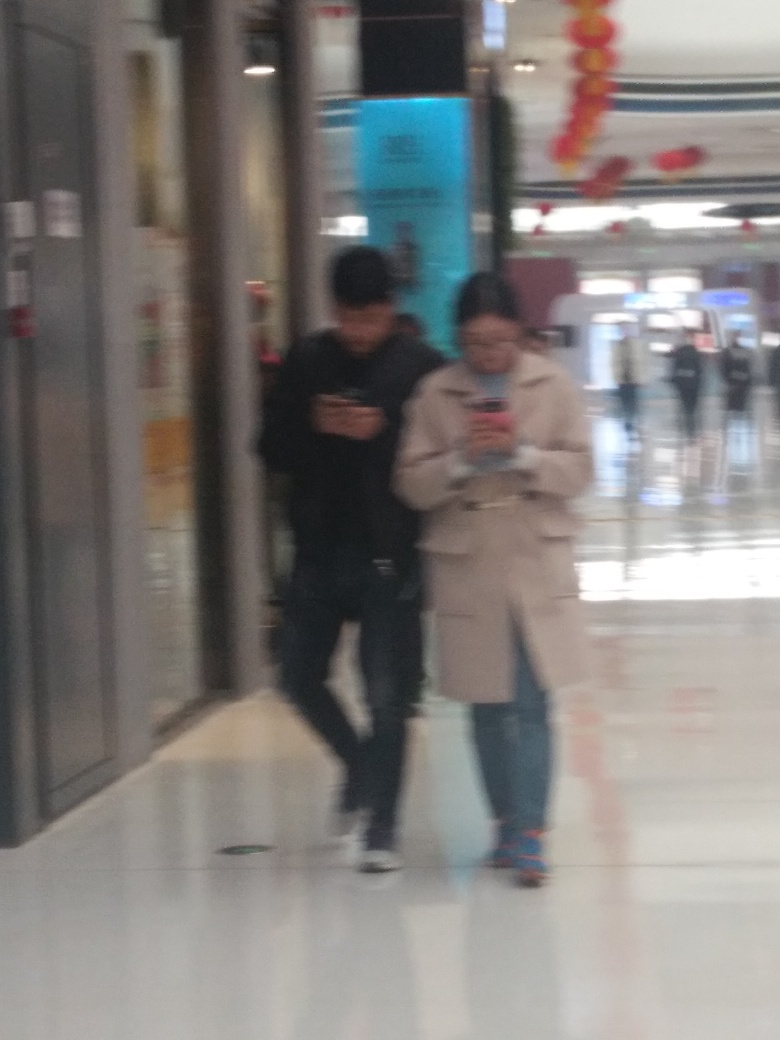Is the quality of this picture good? The quality of the picture is not good because it is blurry and out of focus, which may obscure details and make it difficult to discern specific features or the environment clearly. 